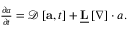Convert formula to latex. <formula><loc_0><loc_0><loc_500><loc_500>\begin{array} { r } { \frac { \partial a } { \partial t } = \mathcal { D } \left [ a , t \right ] + \underline { L } \left [ \nabla \right ] \cdot a . } \end{array}</formula> 